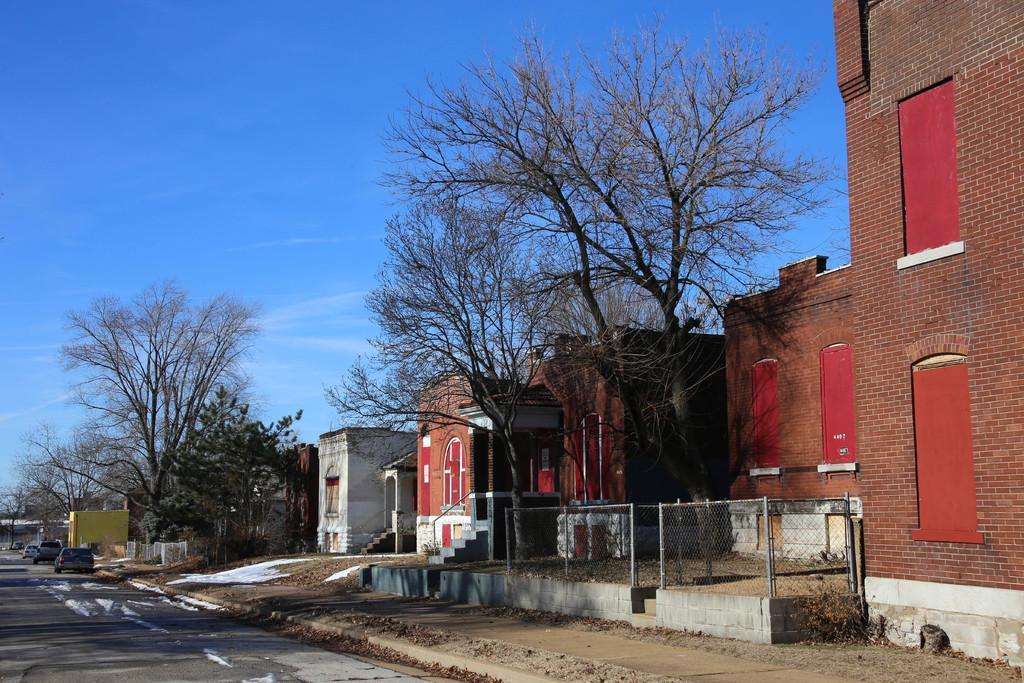Describe this image in one or two sentences. In this image, I can see the buildings, trees, fence and there are vehicles on the road. In the background, there is the sky. 